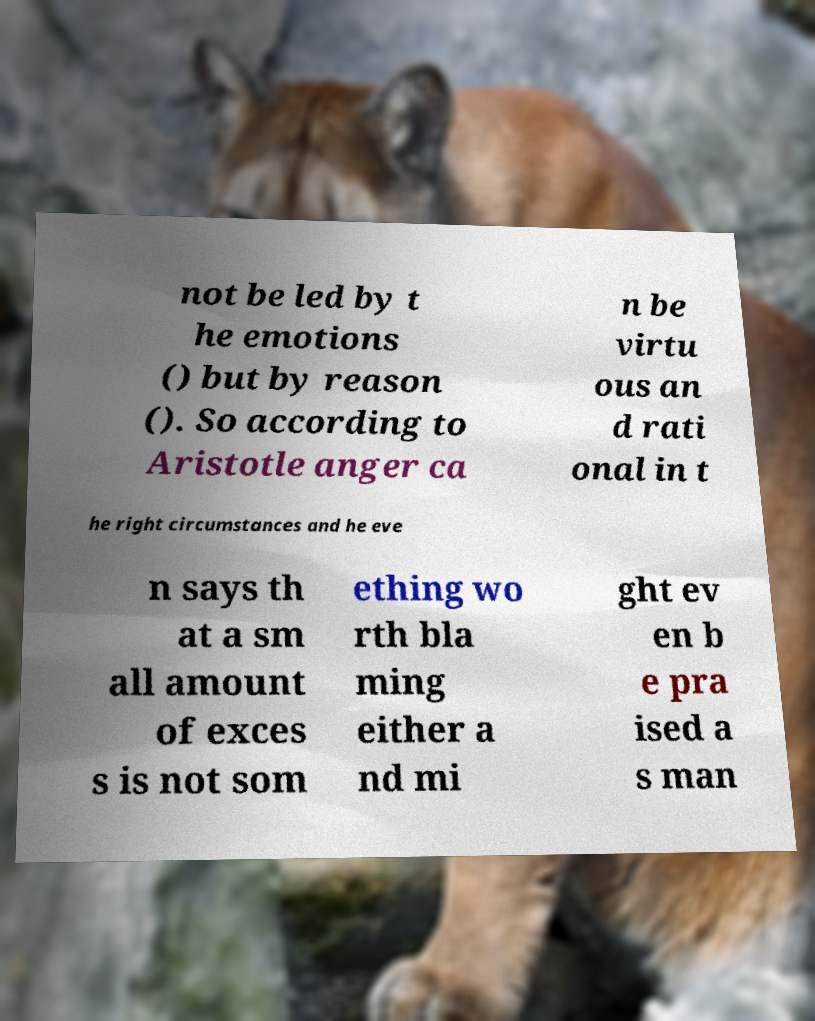Could you extract and type out the text from this image? not be led by t he emotions () but by reason (). So according to Aristotle anger ca n be virtu ous an d rati onal in t he right circumstances and he eve n says th at a sm all amount of exces s is not som ething wo rth bla ming either a nd mi ght ev en b e pra ised a s man 